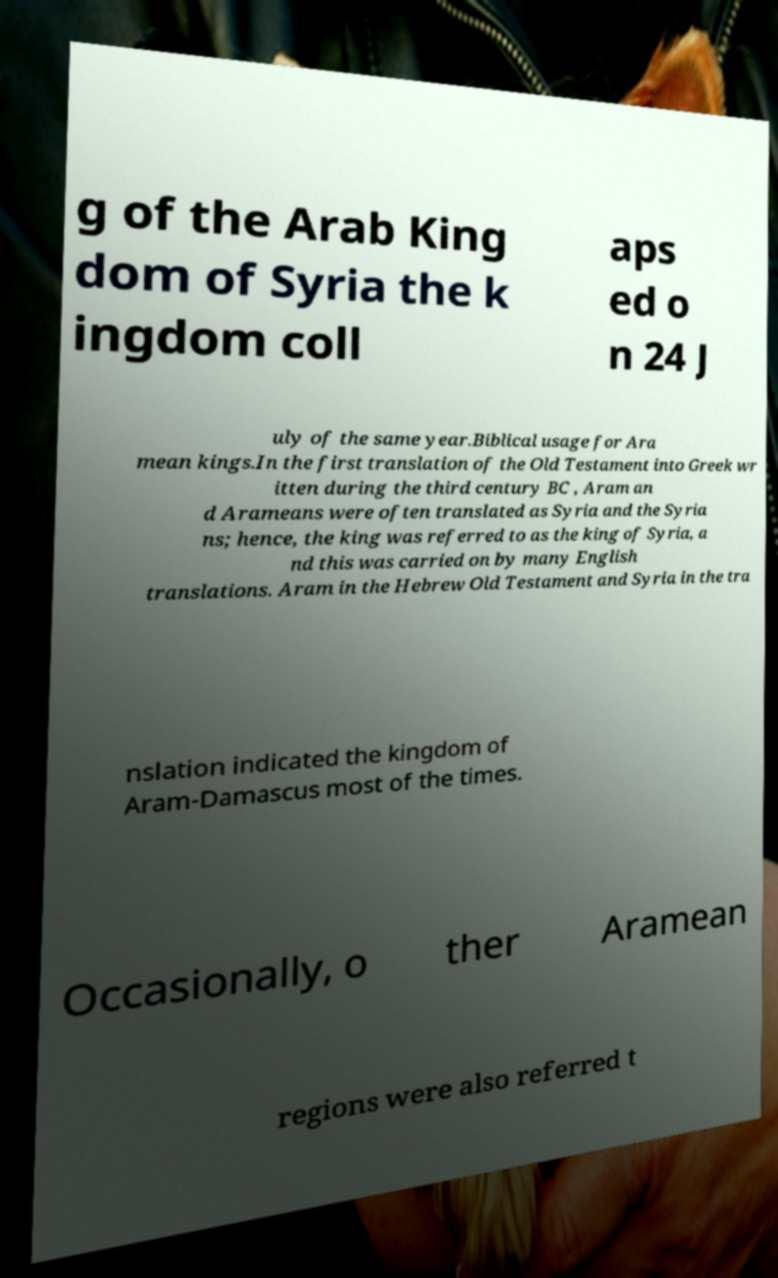What messages or text are displayed in this image? I need them in a readable, typed format. g of the Arab King dom of Syria the k ingdom coll aps ed o n 24 J uly of the same year.Biblical usage for Ara mean kings.In the first translation of the Old Testament into Greek wr itten during the third century BC , Aram an d Arameans were often translated as Syria and the Syria ns; hence, the king was referred to as the king of Syria, a nd this was carried on by many English translations. Aram in the Hebrew Old Testament and Syria in the tra nslation indicated the kingdom of Aram-Damascus most of the times. Occasionally, o ther Aramean regions were also referred t 